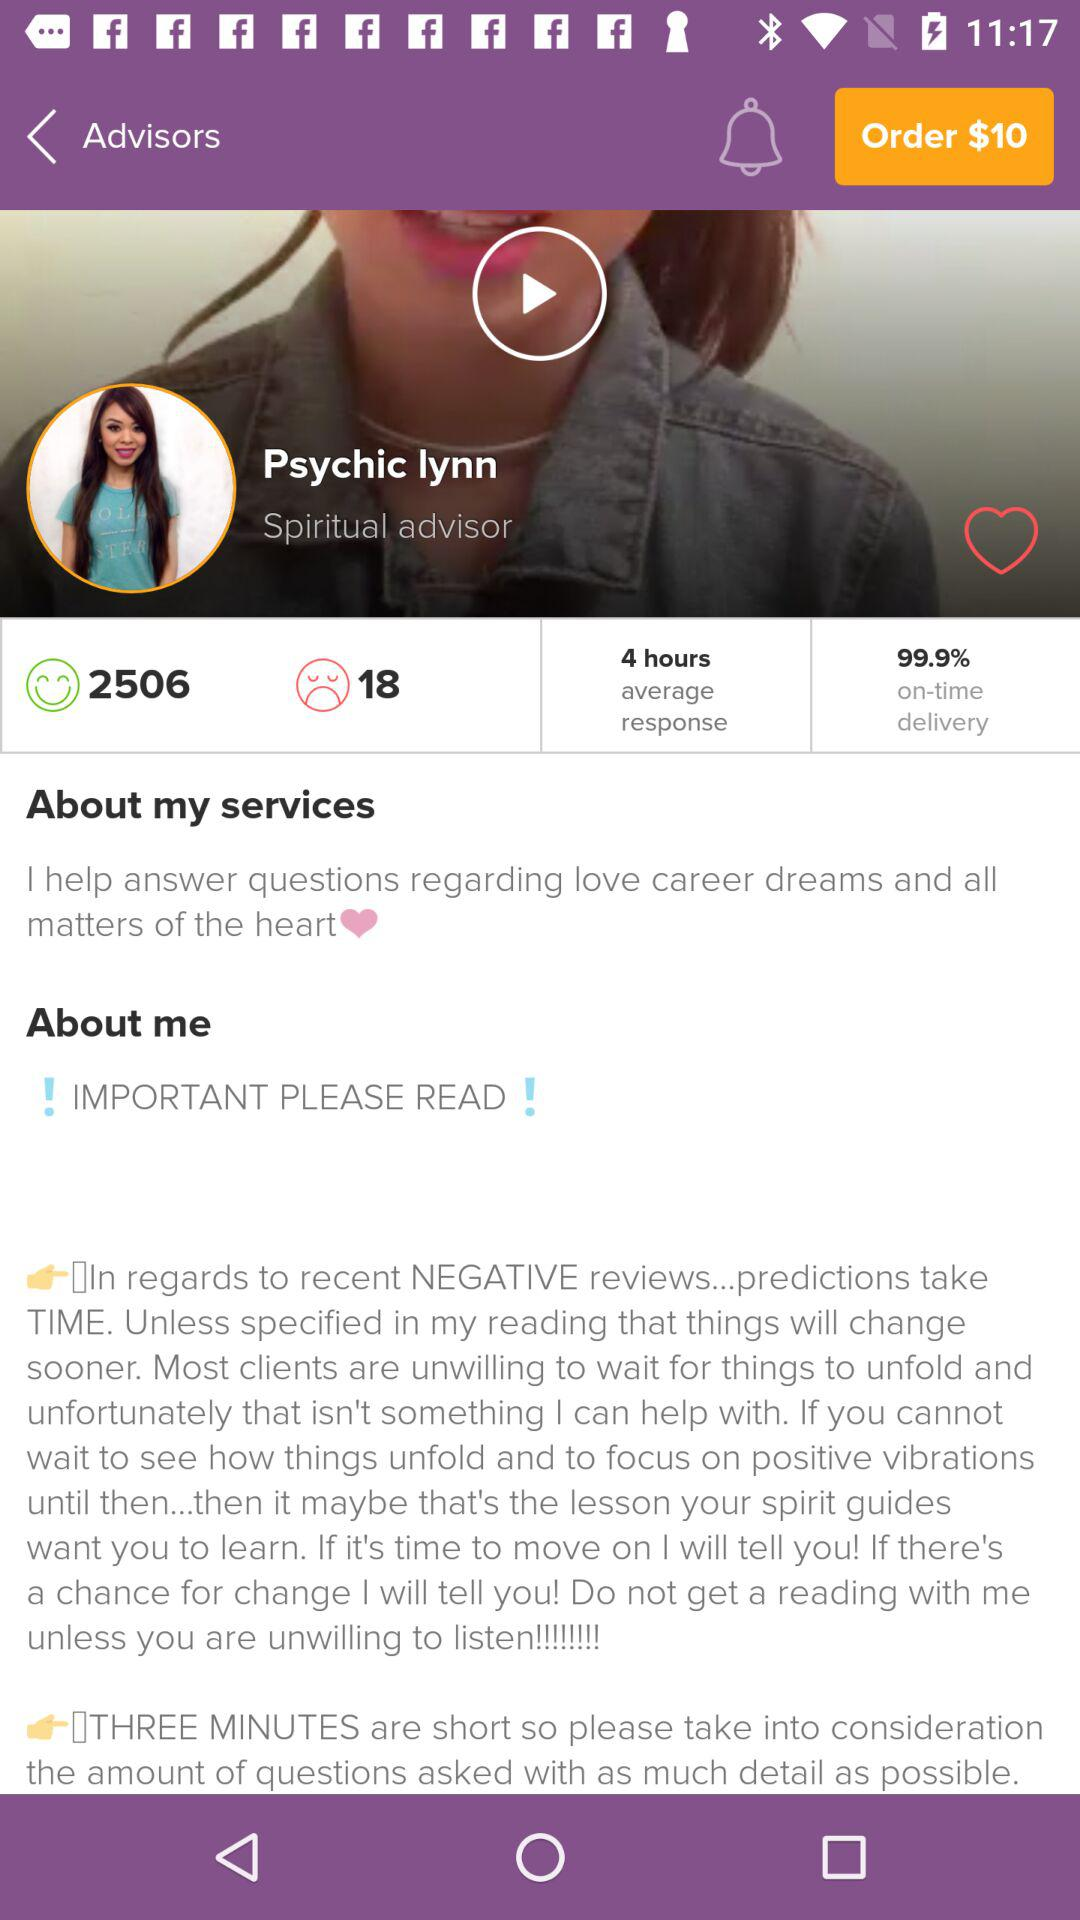What is the advisor's name? The advisor's name is "Psychic Iynn". 